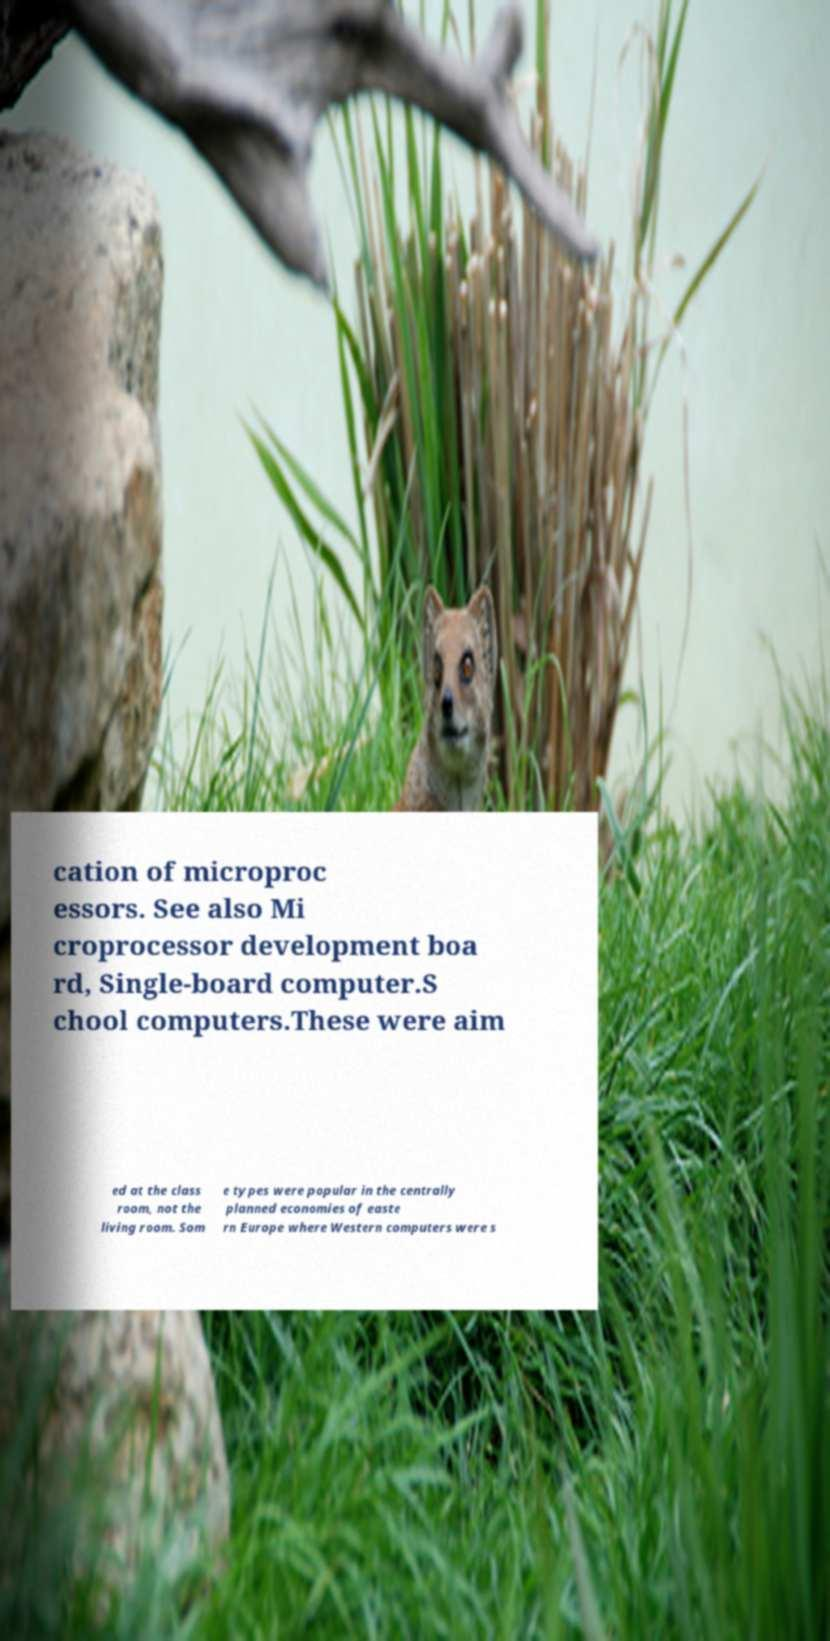Please identify and transcribe the text found in this image. cation of microproc essors. See also Mi croprocessor development boa rd, Single-board computer.S chool computers.These were aim ed at the class room, not the living room. Som e types were popular in the centrally planned economies of easte rn Europe where Western computers were s 